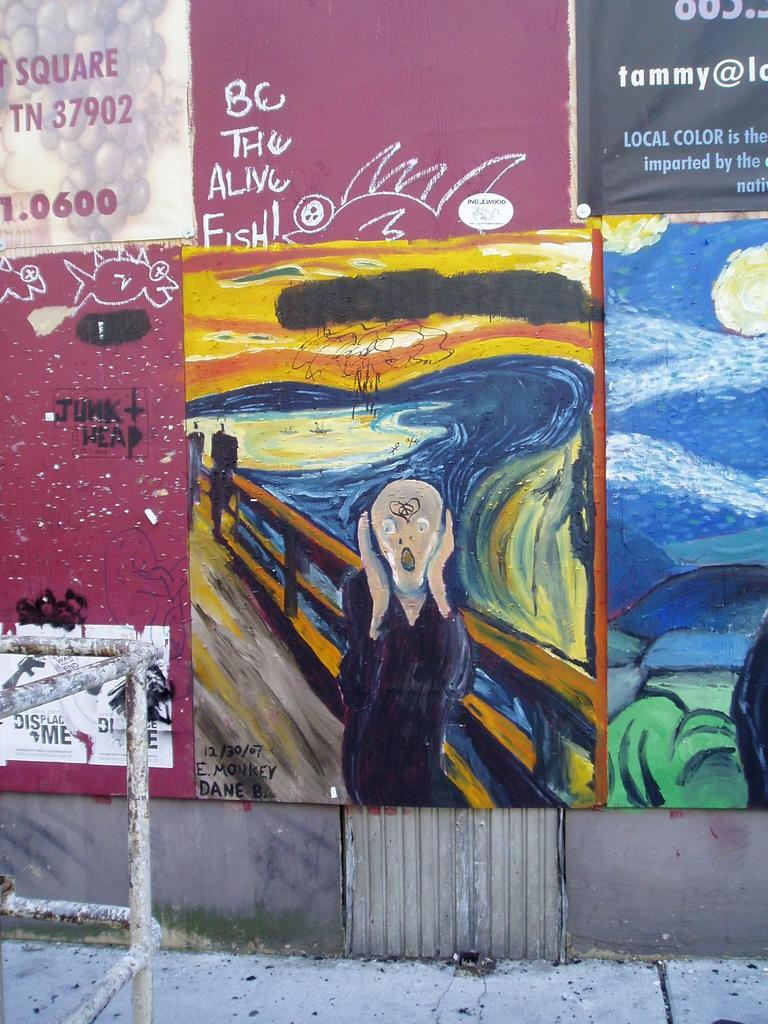Provide a one-sentence caption for the provided image. The email address of a woman named Tammy is one of many things decorating a public wall. 